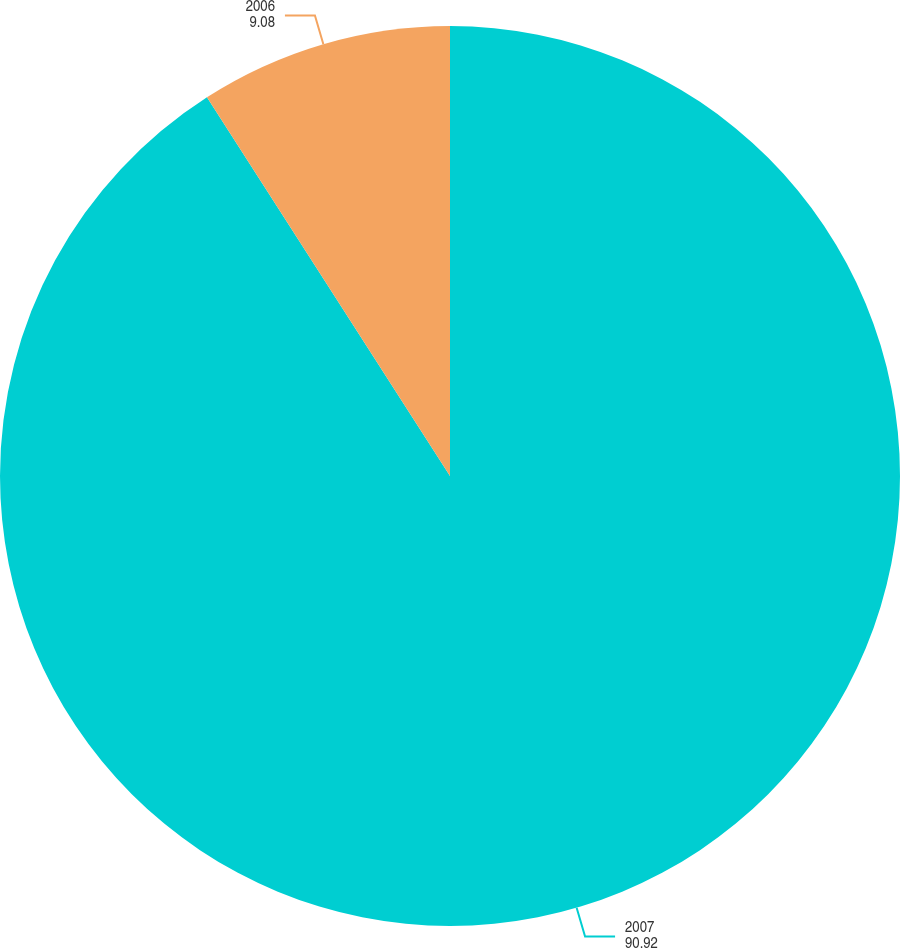Convert chart. <chart><loc_0><loc_0><loc_500><loc_500><pie_chart><fcel>2007<fcel>2006<nl><fcel>90.92%<fcel>9.08%<nl></chart> 